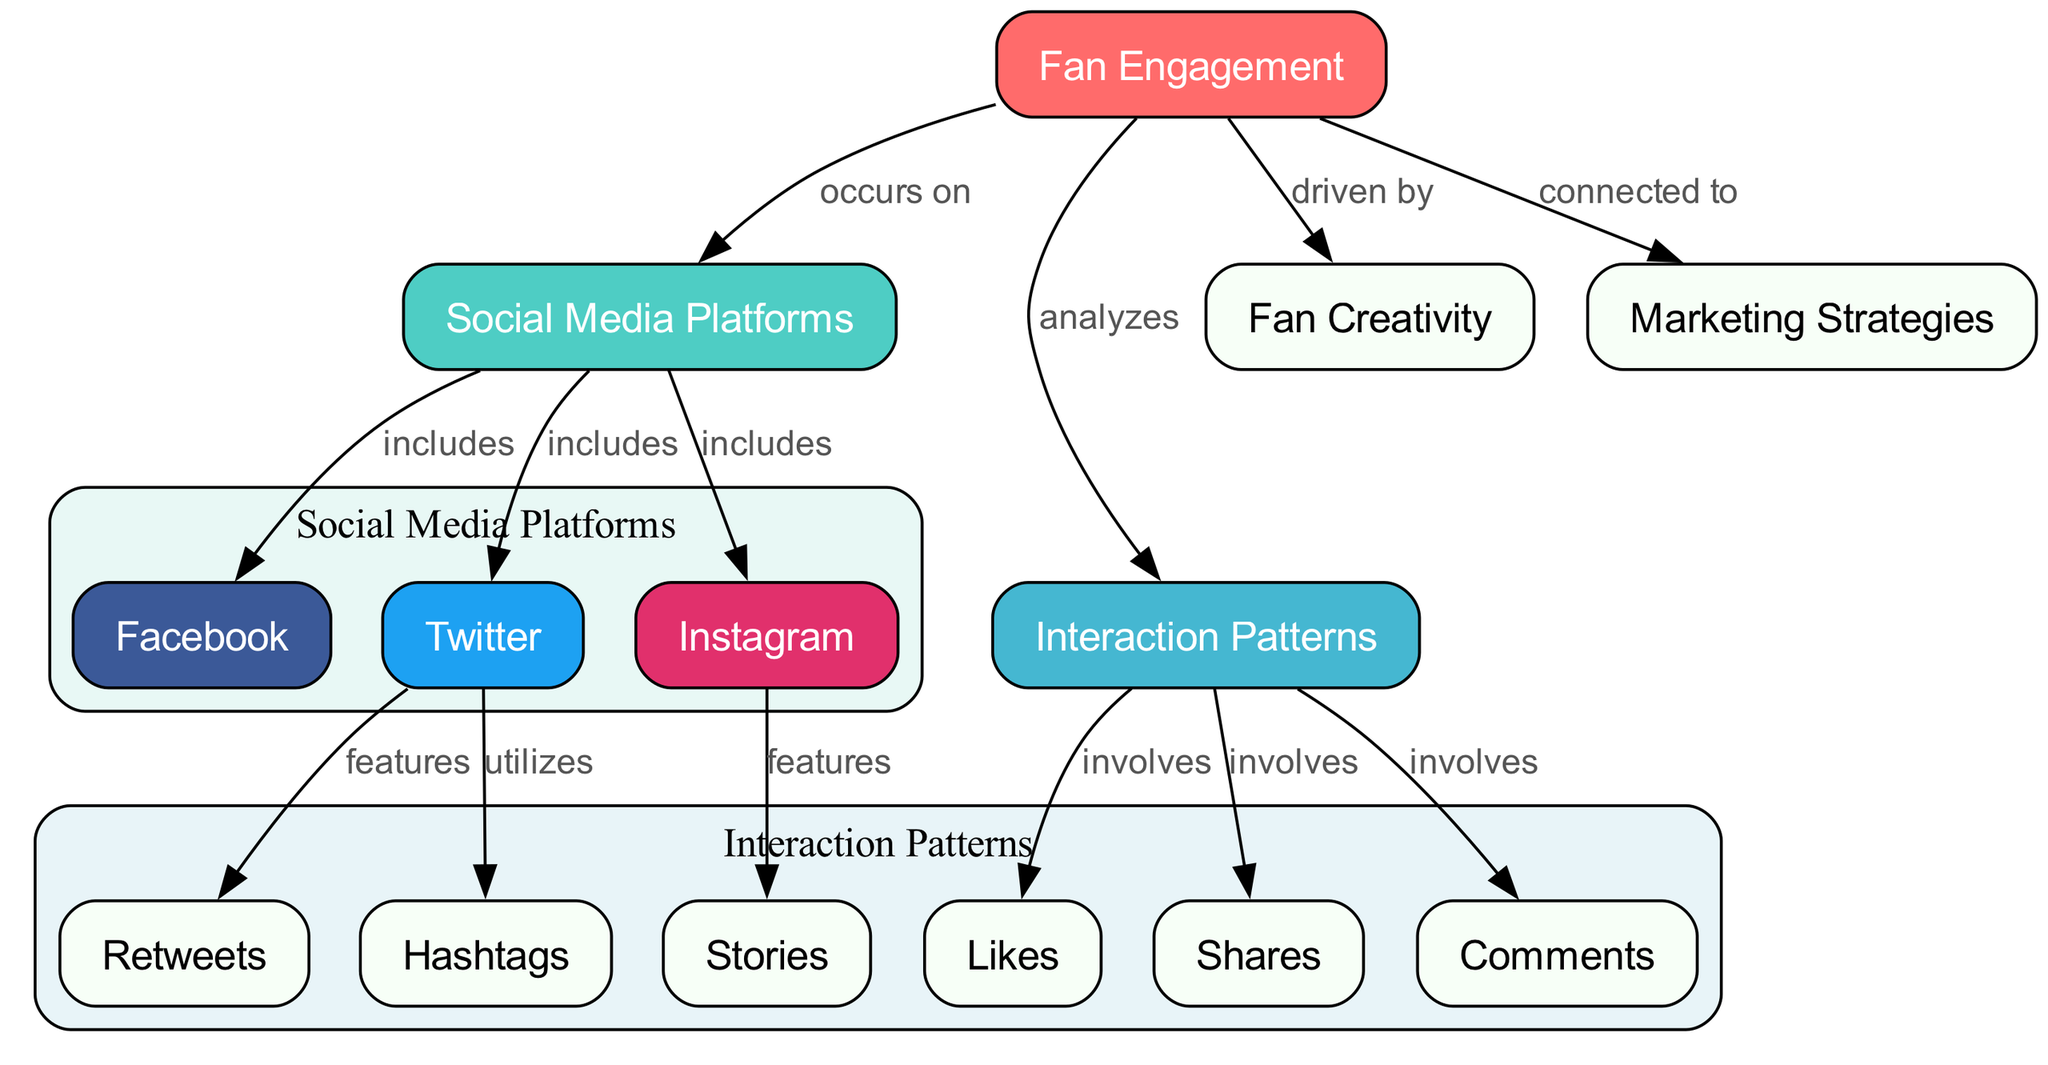What is the main focus of the diagram? The main focus of the diagram is "Fan Engagement," as it is the central node connecting various elements in the diagram.
Answer: Fan Engagement How many social media platforms are included? The diagram lists three social media platforms: Facebook, Twitter, and Instagram, making it a total of three.
Answer: 3 What interactions are analyzed under "Interaction Patterns"? The interactions analyzed include Likes, Shares, Comments, Retweets, Hashtags, and Stories, which collectively represent the types of engagement by fans.
Answer: Likes, Shares, Comments, Retweets, Hashtags, Stories Which social media platform features Stories? According to the diagram, Instagram features Stories as part of its interaction patterns.
Answer: Instagram What is the relationship between Fan Engagement and Fan Creativity? The relationship depicted in the diagram shows that Fan Creativity is driven by Fan Engagement, indicating a causal link between the two concepts.
Answer: driven by How do Twitter and the concept of Hashtags relate? The diagram illustrates that Twitter utilizes Hashtags, indicating a direct relationship where hashtags are a significant feature of the Twitter platform.
Answer: utilizes Which node indicates the types of interactions that occur on the platforms? The "Interaction Patterns" node is where the types of interactions such as Likes, Shares, and Comments are indicated as occurring on the social media platforms.
Answer: Interaction Patterns Which platform includes Retweets as an interaction? The diagram specifies that Twitter features Retweets as part of its interaction patterns, highlighting its unique engagement style.
Answer: Twitter What is connected to Marketing Strategies in the diagram? The diagram shows that Marketing Strategies is connected to Fan Engagement, indicating that the strategies are linked to how fans engage on social media.
Answer: connected to 